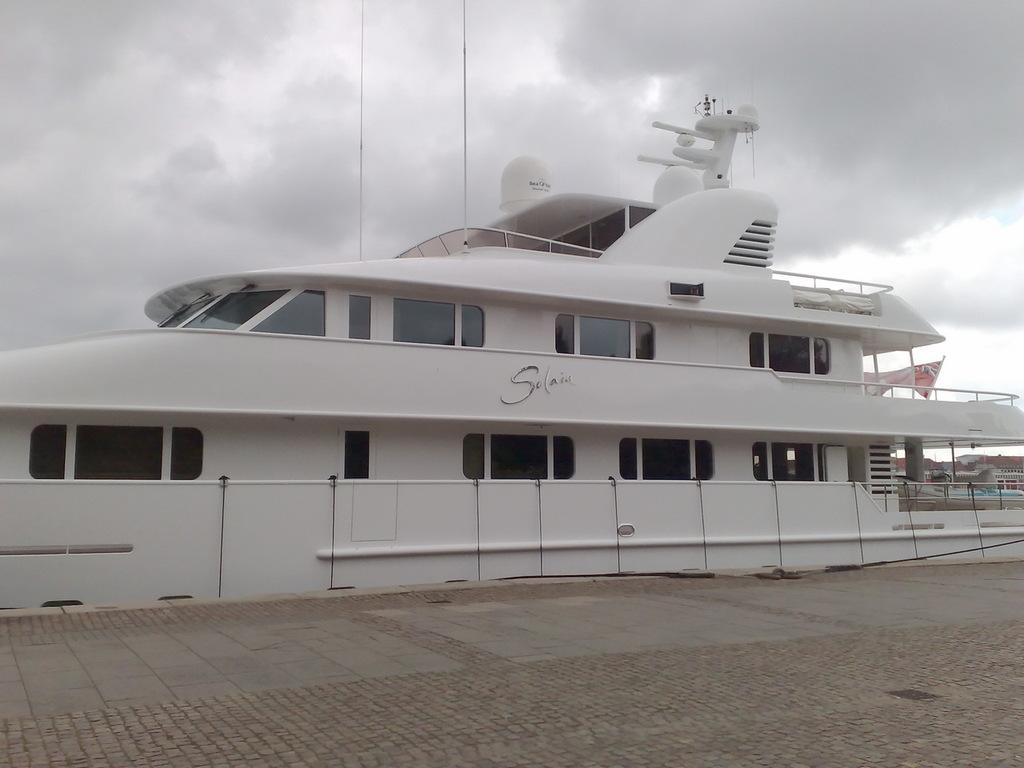What is the main subject of the image? The main subject of the image is a ship. What can be seen at the bottom of the image? There is a path at the bottom of the image. What is visible in the background of the image? The sky and houses are visible in the background of the image. Can you describe the sky in the image? The sky appears to be cloudy in the image. Where is the flag located in the image? The flag is on the right side of the image. What type of religious ceremony is taking place on the ship in the image? There is no indication of a religious ceremony taking place on the ship in the image. Can you describe the curtain hanging on the ship's deck in the image? There is no curtain visible on the ship's deck in the image. 